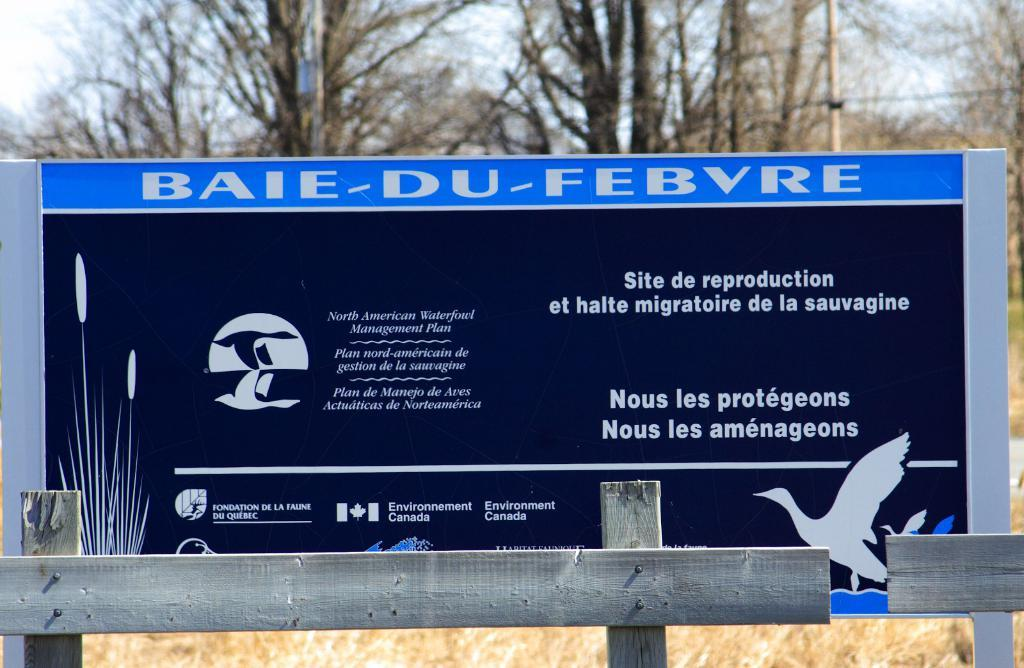Provide a one-sentence caption for the provided image. A sign near a wetland for migratory birds provided by Environment Canada. 